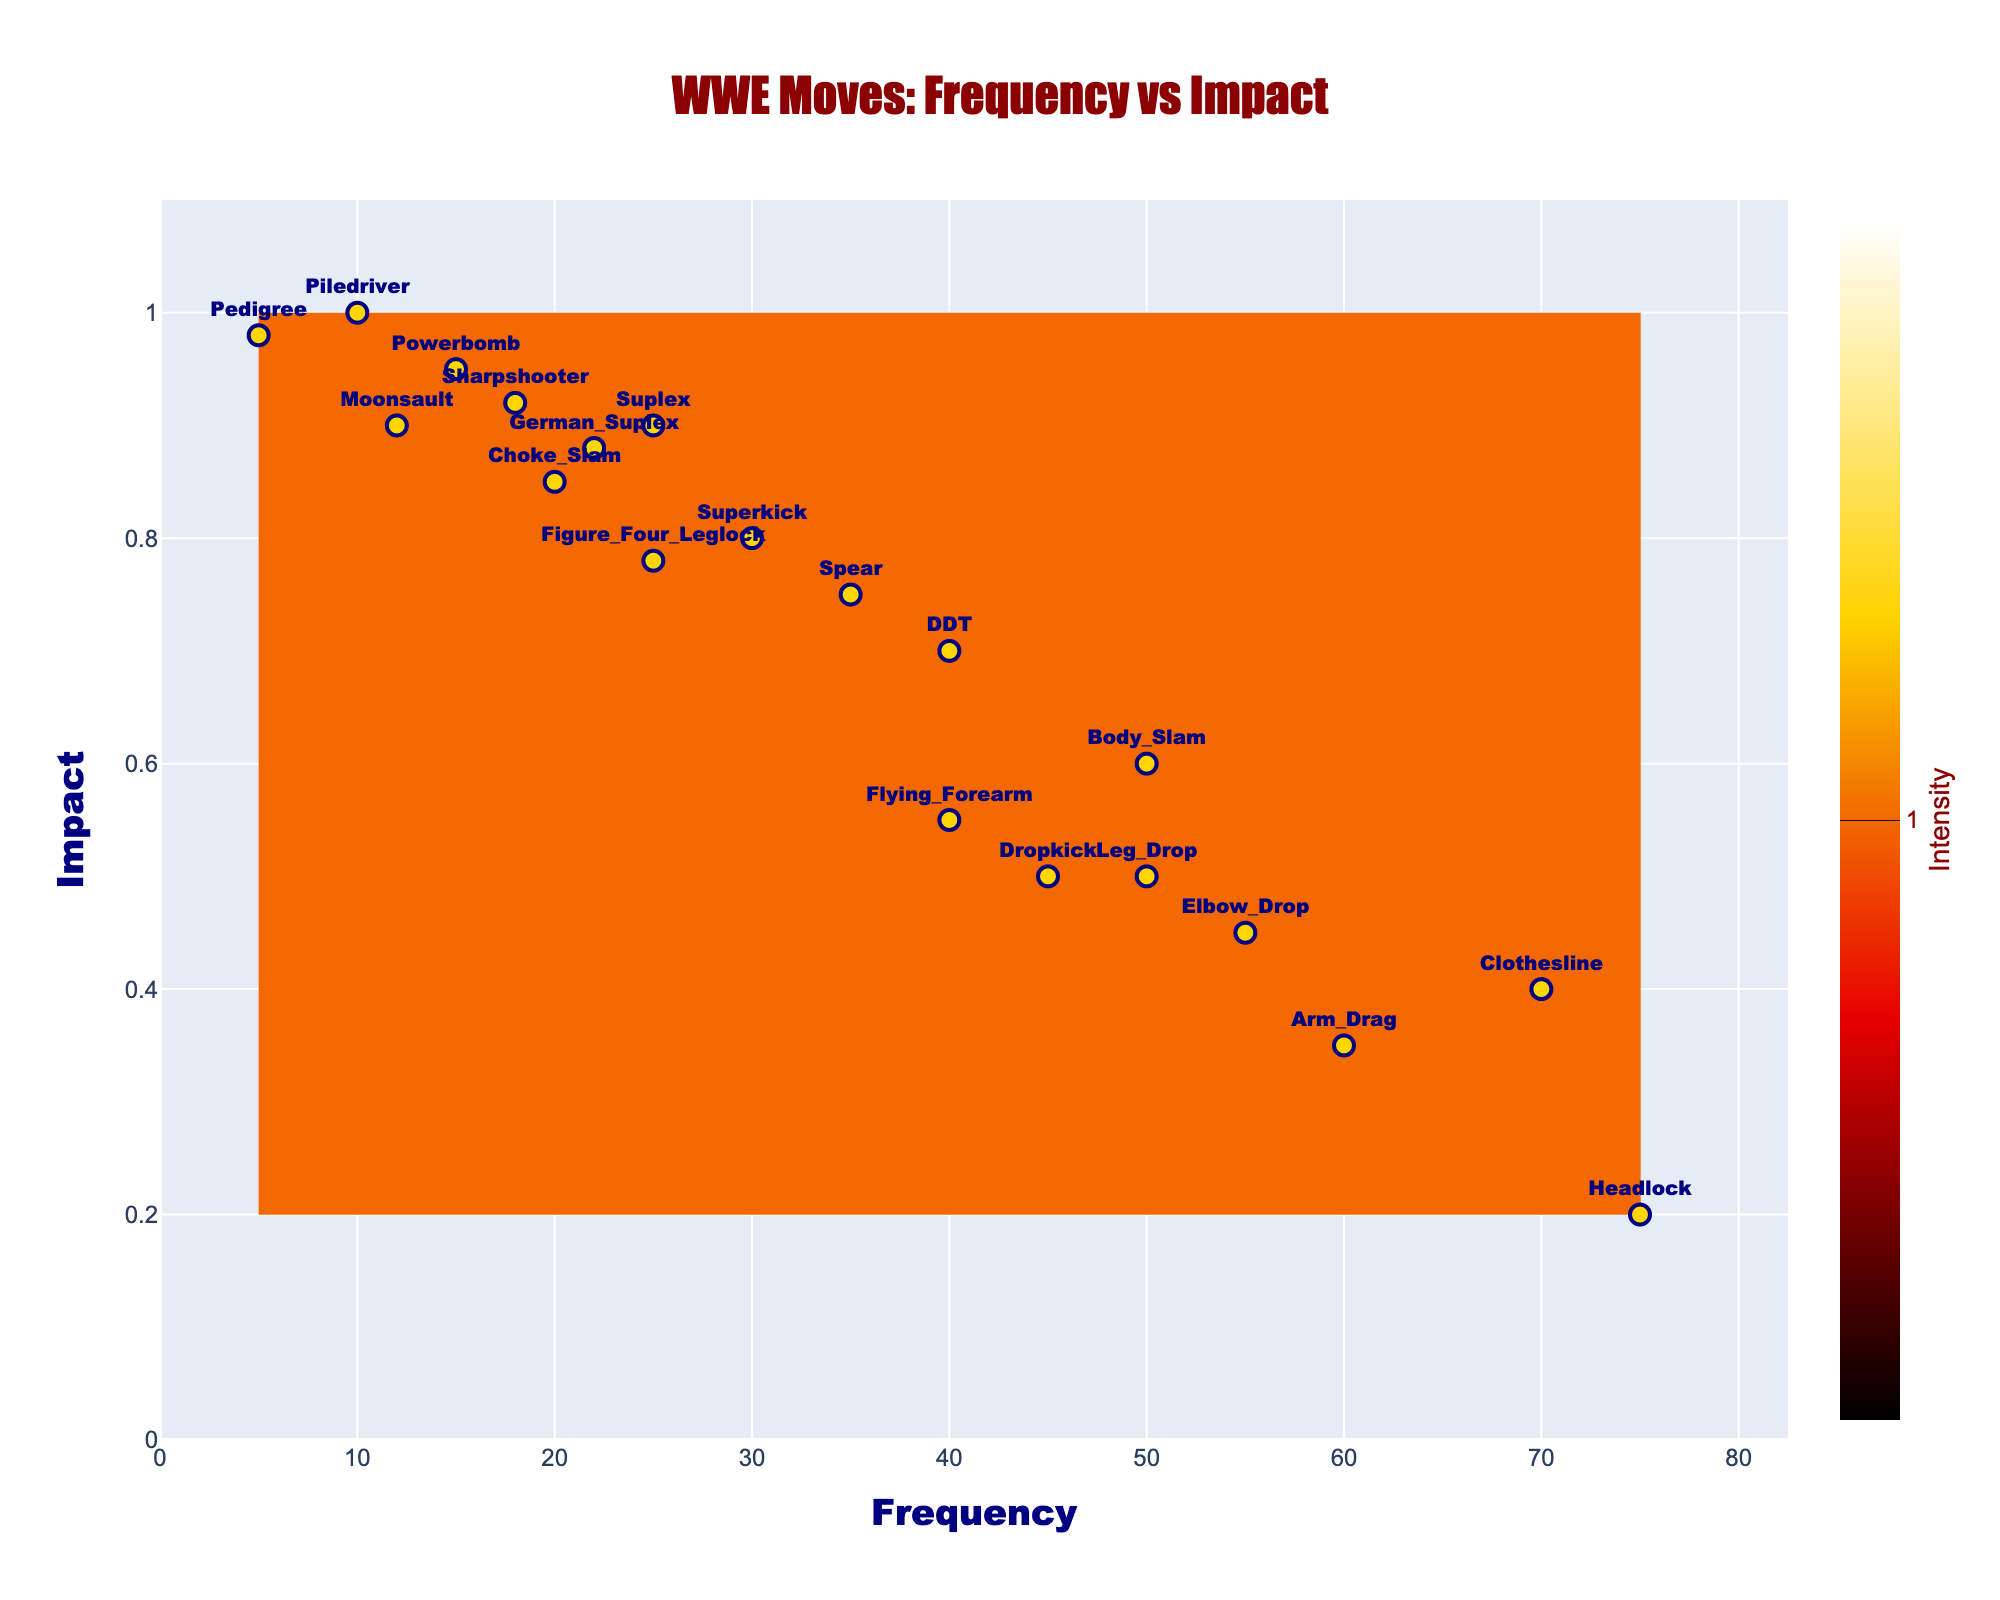What is the title of the figure? The title of the figure is usually displayed at the top of the chart. By inspecting the top part of the figure, you can see the text "WWE Moves: Frequency vs Impact".
Answer: WWE Moves: Frequency vs Impact How many moves are plotted on the figure? The number of data points in the scatter plot corresponds to the number of different moves. By counting the labeled points, you can determine that there are 19 moves shown.
Answer: 19 Which move has the highest frequency? The move with the highest frequency will be the one positioned furthest to the right on the x-axis. By inspecting the x-axis positions, you can identify "Headlock" as the move with the highest frequency at 75.
Answer: Headlock Which move has the highest impact? The move with the highest impact will be positioned at the top of the y-axis. By inspecting the y-axis positions, you can identify "Piledriver" as the move with the highest impact at 1.0.
Answer: Piledriver What is the average frequency of all the moves? To find the average frequency, sum up all the frequencies and divide by the number of moves. Sum of frequencies = 50 + 70 + 45 + 30 + 25 + 15 + 40 + 10 + 55 + 60 + 75 + 20 + 22 + 12 + 50 + 40 + 35 + 18 + 25 + 5 = 702. Number of moves = 19. Average = 702 / 19.
Answer: 36.95 What is the frequency range of moves with an impact greater than 0.8? First, identify the moves with an impact greater than 0.8: "Superkick", "Suplex", "Powerbomb", "Piledriver", "Choke Slam", "German Suplex", "Moonsault", "Sharpshooter", "Pedigree". Then, find the minimum and maximum frequency of these moves: minimum frequency = 5 (Pedigree) and maximum frequency = 30 (Superkick).
Answer: 5 - 30 Which move has the highest frequency in the impact range 0.5 to 0.7? Identify the moves within the impact range 0.5 to 0.7: "Body Slam", "Dropkick", "Leg Drop", "Flying Forearm", "DDT". Of these moves, "Body Slam" has the highest frequency at 50.
Answer: Body Slam How does the frequency of "Clothesline" compare to "Spear"? By comparing their x-axis positions, you can see that the frequency of "Clothesline" (70) is greater than the frequency of "Spear" (35).
Answer: Clothesline is greater What is the median impact value of all the moves? Arrange the impact values in ascending order and identify the middle value: [0.2, 0.35, 0.4, 0.45, 0.5, 0.5, 0.55, 0.6, 0.7, 0.75, 0.78, 0.8, 0.85, 0.88, 0.9, 0.9, 0.92, 0.95, 1.0]. The median (middle) value is the 10th value in this sorted list.
Answer: 0.75 